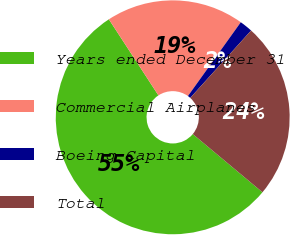<chart> <loc_0><loc_0><loc_500><loc_500><pie_chart><fcel>Years ended December 31<fcel>Commercial Airplanes<fcel>Boeing Capital<fcel>Total<nl><fcel>54.74%<fcel>19.08%<fcel>1.8%<fcel>24.38%<nl></chart> 